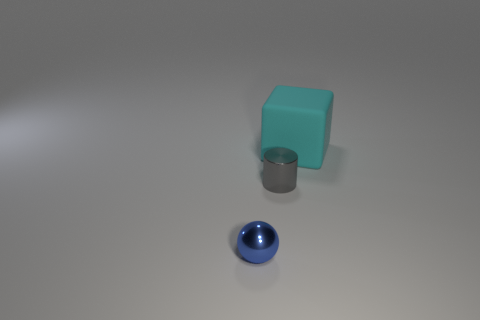Can you tell if the lighting is natural or artificial? The shadows cast by the objects and the overall lighting suggest an artificial source, likely positioned above and to the right of the scene, given the angle and diffusion of the shadows. Is there a sense of perspective or depth in this image? Yes, there's a sense of depth created by the spatial arrangement of the objects and the gradient of the surface on which they rest, which suggests a light source and perspective. 